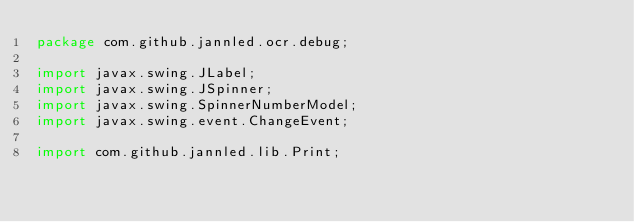Convert code to text. <code><loc_0><loc_0><loc_500><loc_500><_Java_>package com.github.jannled.ocr.debug;

import javax.swing.JLabel;
import javax.swing.JSpinner;
import javax.swing.SpinnerNumberModel;
import javax.swing.event.ChangeEvent;

import com.github.jannled.lib.Print;</code> 